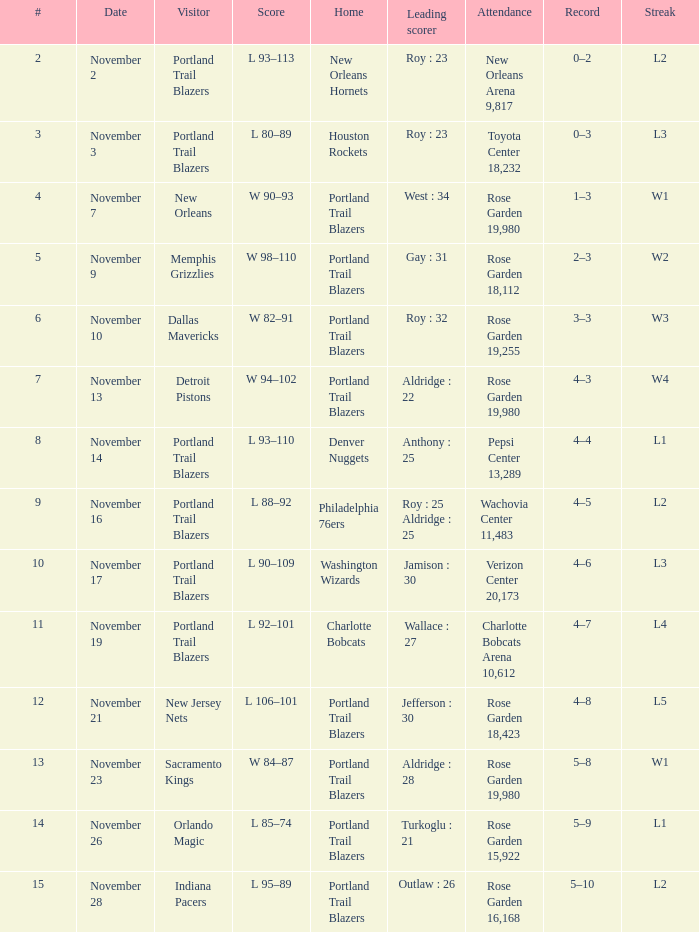 what's the score where record is 0–2 L 93–113. 